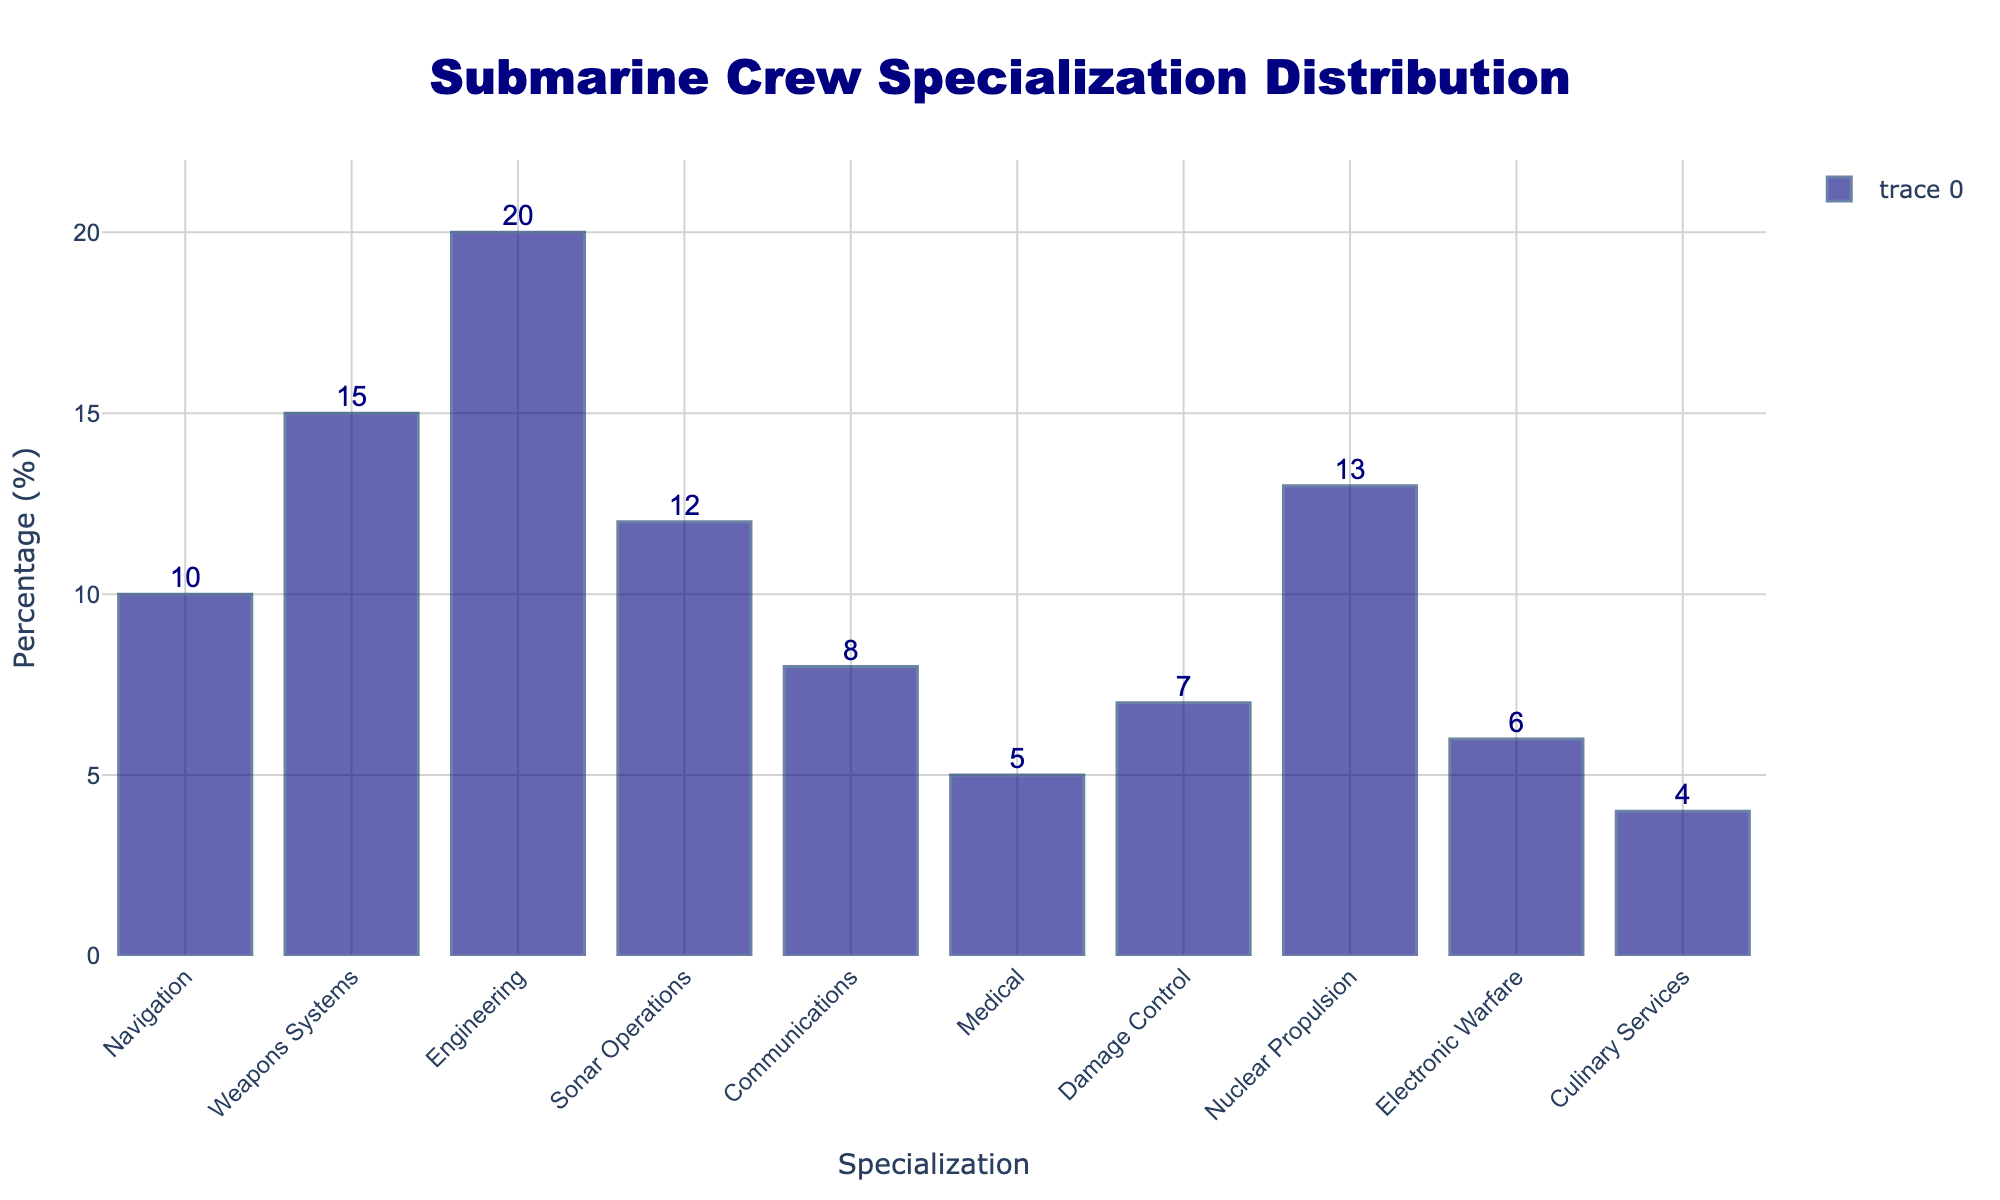Which specialization has the highest percentage? By visually inspecting the heights of the bars, we notice that Engineering has the highest percentage.
Answer: Engineering What is the total percentage of the top three specializations? To find the total percentage of the top three specializations (Engineering, Weapons Systems, Nuclear Propulsion), sum their values: 20 + 15 + 13 = 48%.
Answer: 48% Which specialization fields collectively make up less than 10% each? By examining the individual bar heights, the specializations with percentages under 10% are Communications (8%), Medical (5%), Damage Control (7%), Electronic Warfare (6%), and Culinary Services (4%).
Answer: Communications, Medical, Damage Control, Electronic Warfare, Culinary Services How many specializations have a percentage greater than 10%? Count the number of bars that visually extend beyond the 10% mark. These are Navigation, Weapons Systems, Engineering, Sonar Operations, and Nuclear Propulsion, totaling five specializations.
Answer: 5 What is the percentage difference between the highest and lowest specialization? Determine the values of the highest (Engineering at 20%) and lowest (Culinary Services at 4%), then subtract: 20 - 4 = 16%.
Answer: 16% What is the average percentage of all specializations? Sum all percentages and divide by the number of specializations: (10 + 15 + 20 + 12 + 8 + 5 + 7 + 13 + 6 + 4) / 10 = 100 / 10 = 10%.
Answer: 10% Which two specializations have a combined percentage of exactly 18%? Identify the specialization pairs whose percentages sum to 18%. The pair is Navigation (10%) and Communications (8%), summing to 18%.
Answer: Navigation and Communications Which specialization has the closest percentage to the average specialization percentage? The average percentage is 10%. Among the specializations, Navigation and Sonar Operations both have values closest to this average (10% and 12%, respectively).
Answer: Navigation What percentage of the crew is dedicated to medical roles? From the bar corresponding to Medical, we see the percentage is 5%.
Answer: 5% 